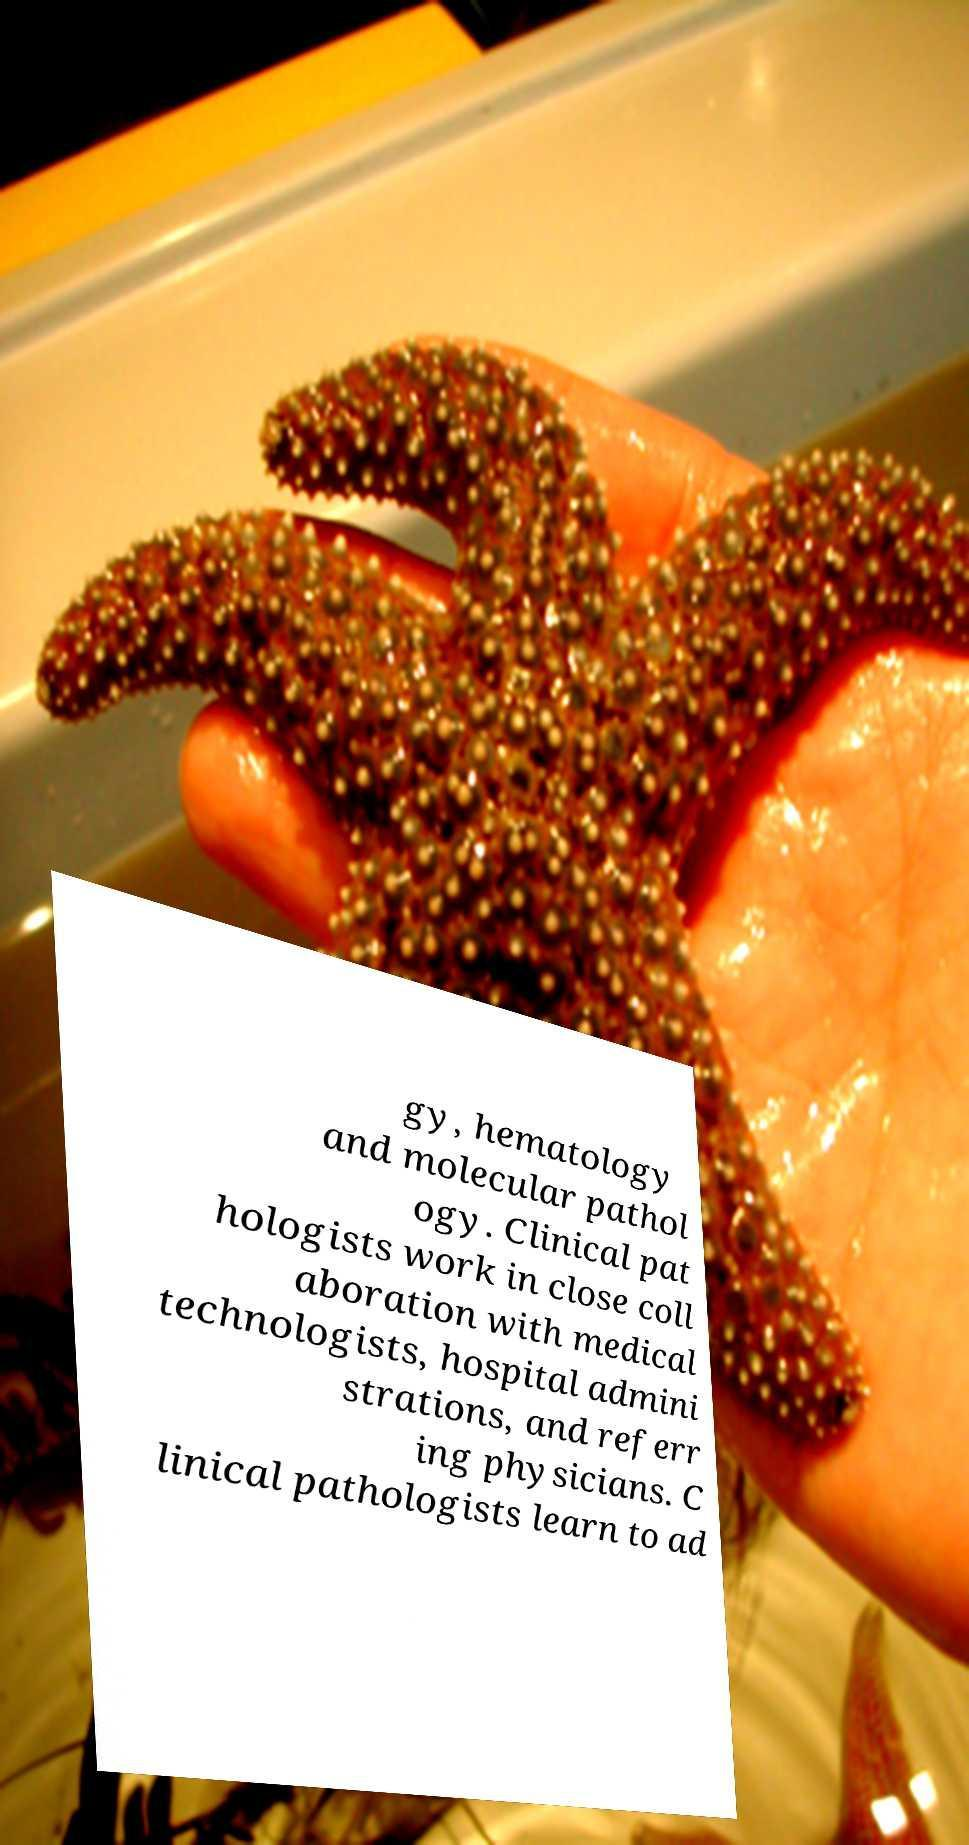For documentation purposes, I need the text within this image transcribed. Could you provide that? gy, hematology and molecular pathol ogy. Clinical pat hologists work in close coll aboration with medical technologists, hospital admini strations, and referr ing physicians. C linical pathologists learn to ad 